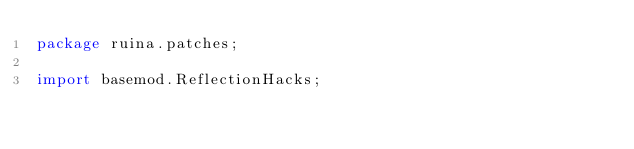Convert code to text. <code><loc_0><loc_0><loc_500><loc_500><_Java_>package ruina.patches;

import basemod.ReflectionHacks;</code> 